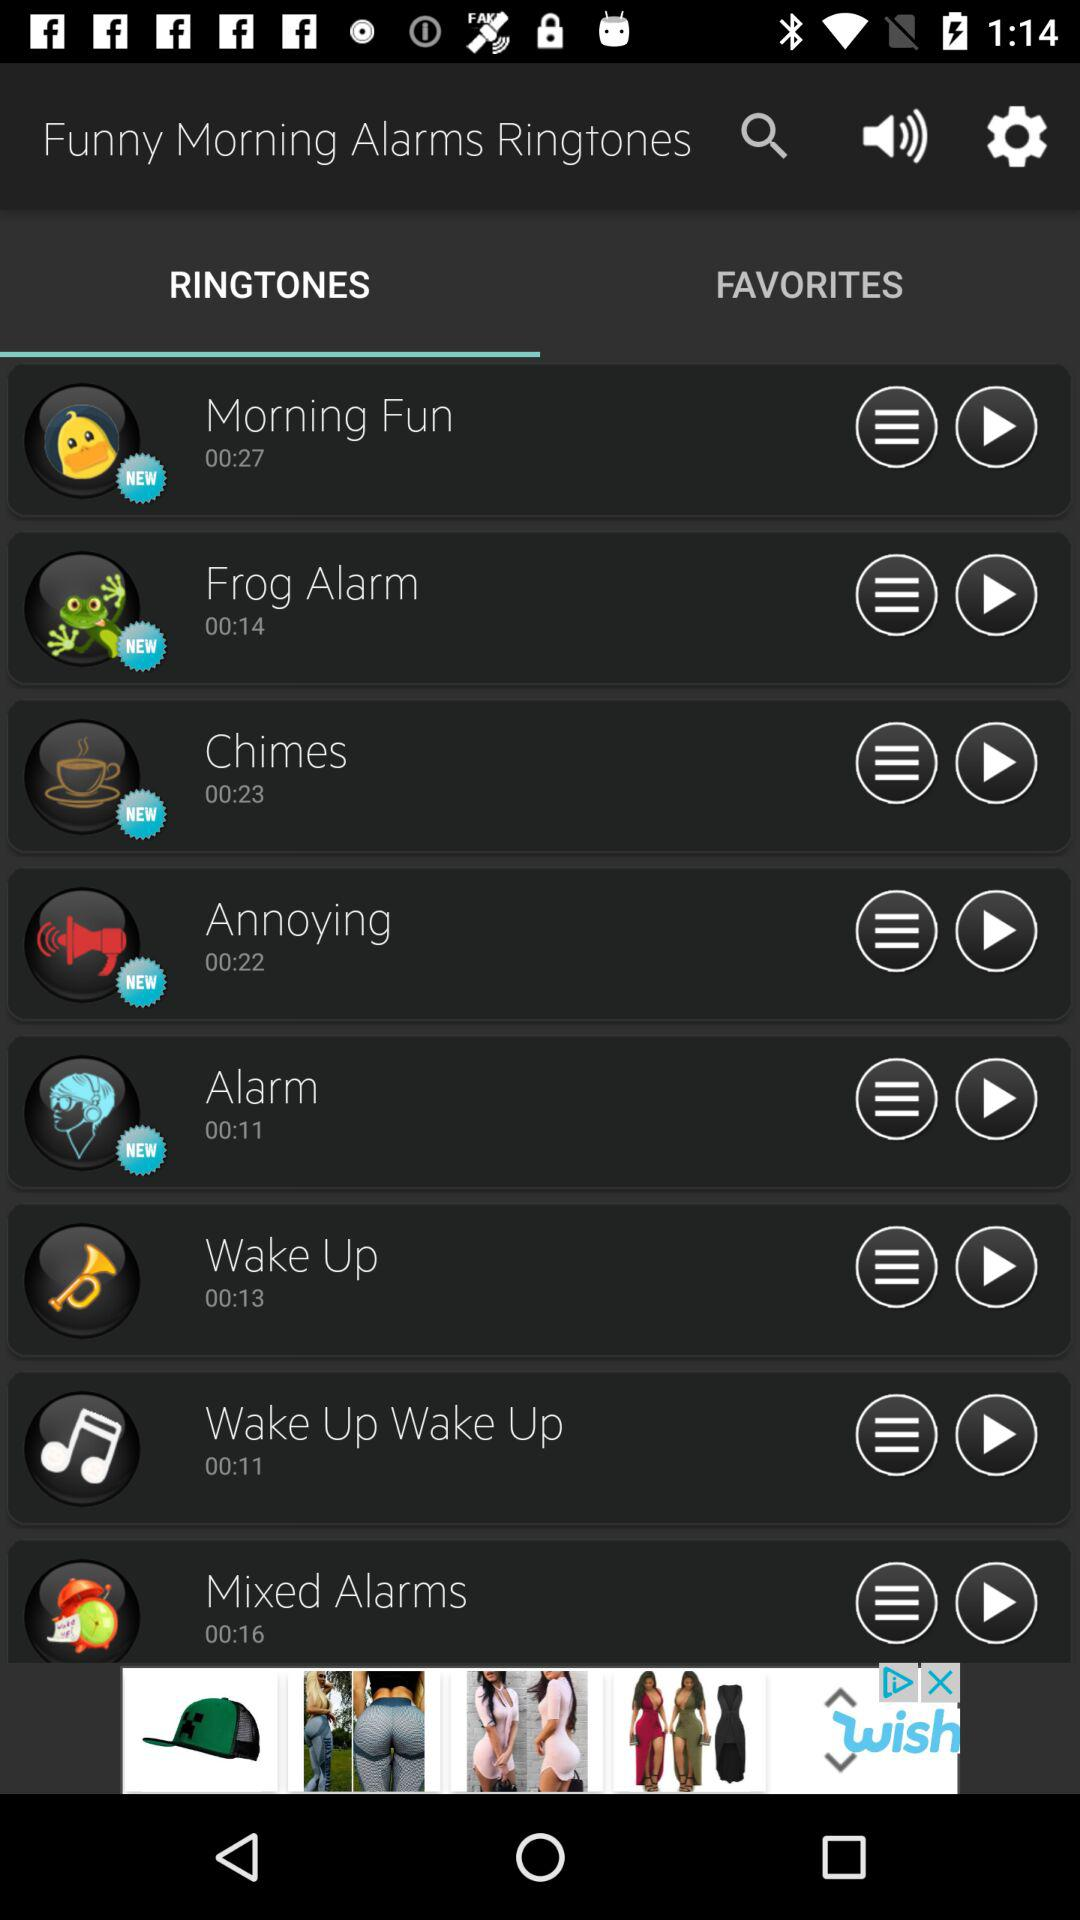What is the duration of the "Alarm"? The duration of the "Alarm" is 11 seconds. 